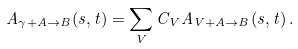<formula> <loc_0><loc_0><loc_500><loc_500>A _ { \gamma + A \rightarrow B } ( s , t ) = \sum _ { V } C _ { V } A _ { V + A \rightarrow B } ( s , t ) \, .</formula> 